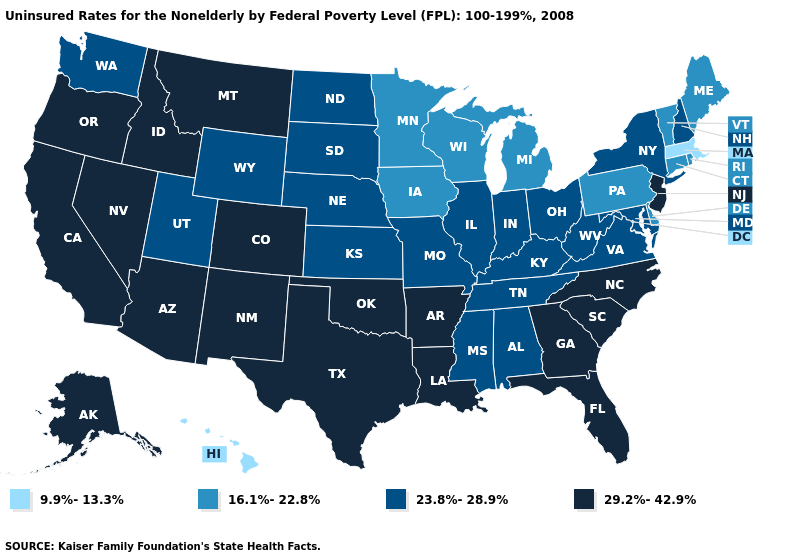Name the states that have a value in the range 16.1%-22.8%?
Write a very short answer. Connecticut, Delaware, Iowa, Maine, Michigan, Minnesota, Pennsylvania, Rhode Island, Vermont, Wisconsin. Which states have the highest value in the USA?
Short answer required. Alaska, Arizona, Arkansas, California, Colorado, Florida, Georgia, Idaho, Louisiana, Montana, Nevada, New Jersey, New Mexico, North Carolina, Oklahoma, Oregon, South Carolina, Texas. How many symbols are there in the legend?
Give a very brief answer. 4. Name the states that have a value in the range 9.9%-13.3%?
Give a very brief answer. Hawaii, Massachusetts. Name the states that have a value in the range 23.8%-28.9%?
Write a very short answer. Alabama, Illinois, Indiana, Kansas, Kentucky, Maryland, Mississippi, Missouri, Nebraska, New Hampshire, New York, North Dakota, Ohio, South Dakota, Tennessee, Utah, Virginia, Washington, West Virginia, Wyoming. What is the value of Vermont?
Be succinct. 16.1%-22.8%. Does the map have missing data?
Concise answer only. No. What is the highest value in the Northeast ?
Be succinct. 29.2%-42.9%. What is the value of Arizona?
Concise answer only. 29.2%-42.9%. Among the states that border Georgia , does Alabama have the lowest value?
Be succinct. Yes. How many symbols are there in the legend?
Give a very brief answer. 4. What is the value of West Virginia?
Give a very brief answer. 23.8%-28.9%. What is the value of Connecticut?
Be succinct. 16.1%-22.8%. Name the states that have a value in the range 9.9%-13.3%?
Give a very brief answer. Hawaii, Massachusetts. Name the states that have a value in the range 9.9%-13.3%?
Short answer required. Hawaii, Massachusetts. 